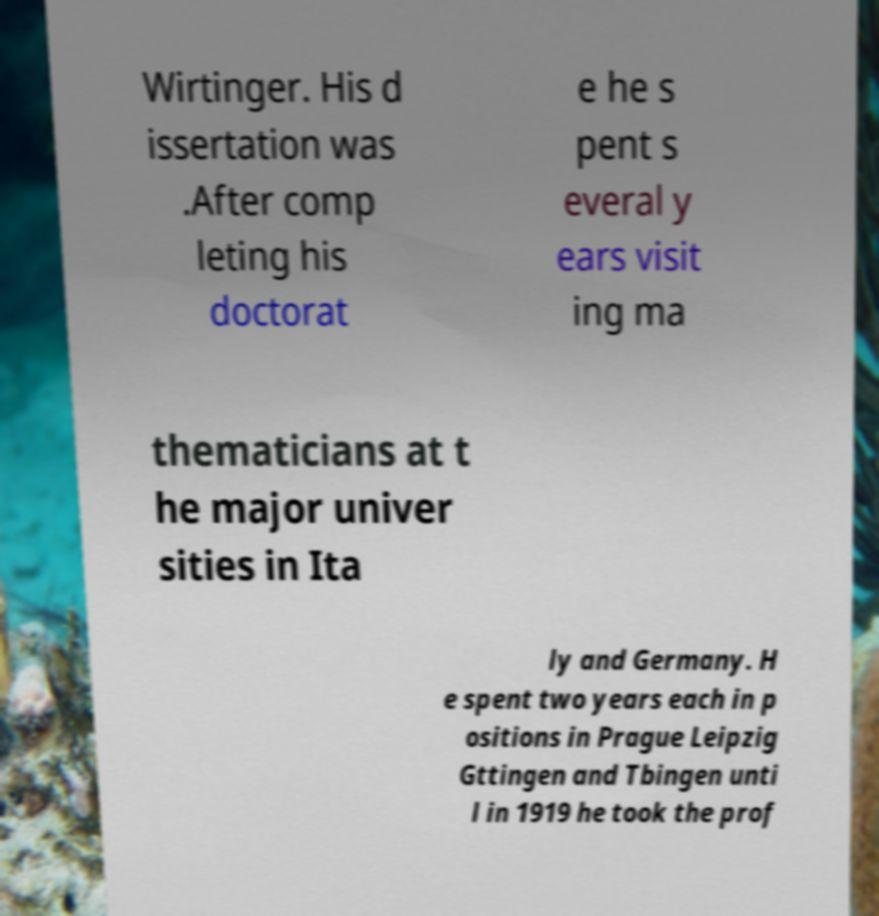For documentation purposes, I need the text within this image transcribed. Could you provide that? Wirtinger. His d issertation was .After comp leting his doctorat e he s pent s everal y ears visit ing ma thematicians at t he major univer sities in Ita ly and Germany. H e spent two years each in p ositions in Prague Leipzig Gttingen and Tbingen unti l in 1919 he took the prof 